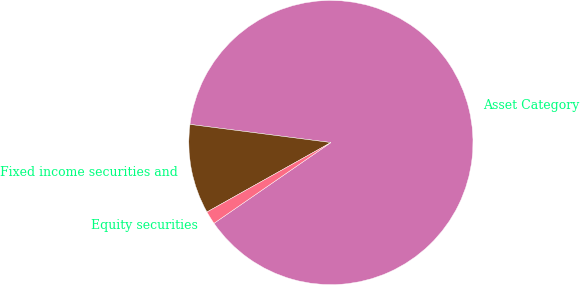Convert chart to OTSL. <chart><loc_0><loc_0><loc_500><loc_500><pie_chart><fcel>Asset Category<fcel>Fixed income securities and<fcel>Equity securities<nl><fcel>88.34%<fcel>10.17%<fcel>1.49%<nl></chart> 